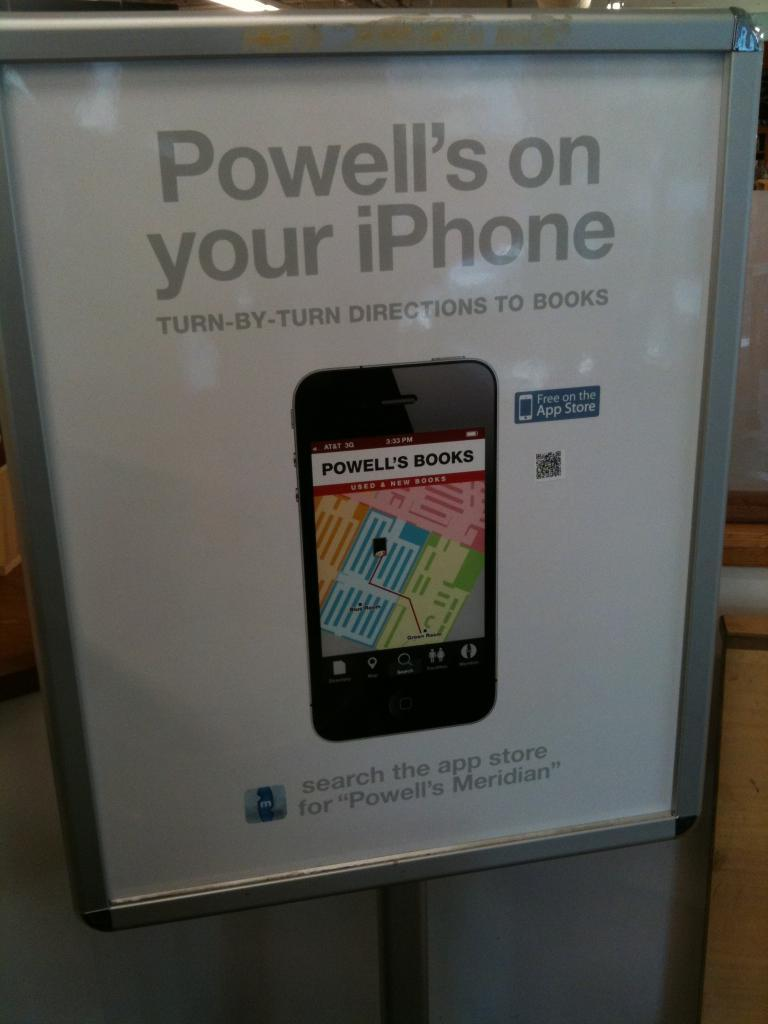<image>
Offer a succinct explanation of the picture presented. an advert for an iphone with the word Powell's prominent 